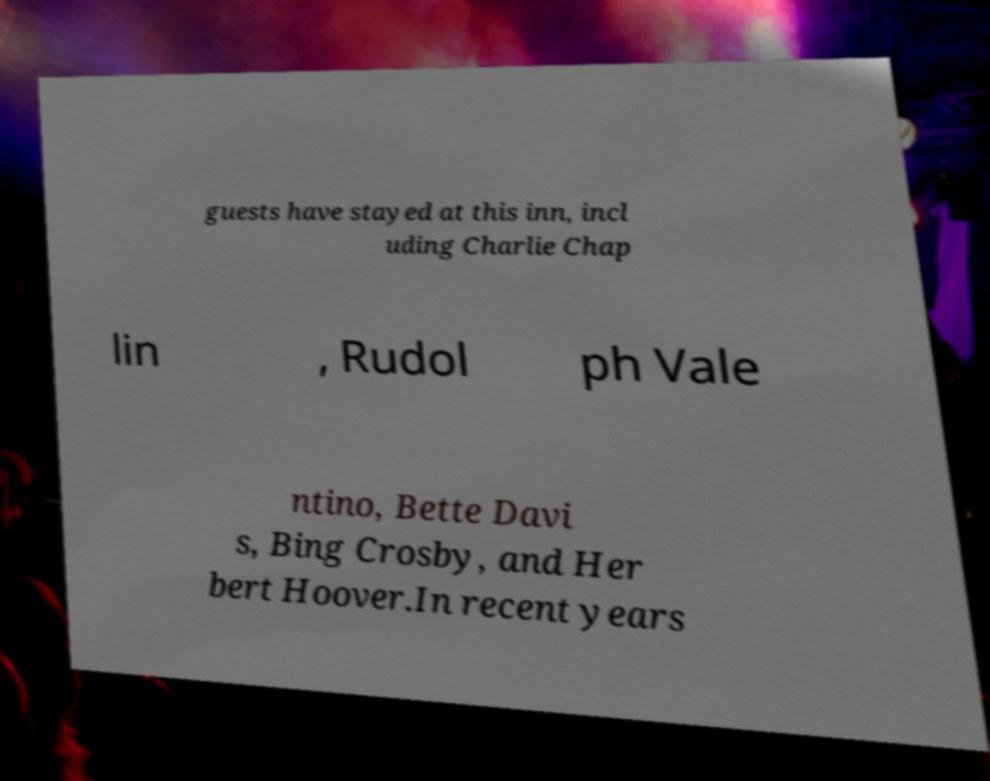There's text embedded in this image that I need extracted. Can you transcribe it verbatim? guests have stayed at this inn, incl uding Charlie Chap lin , Rudol ph Vale ntino, Bette Davi s, Bing Crosby, and Her bert Hoover.In recent years 